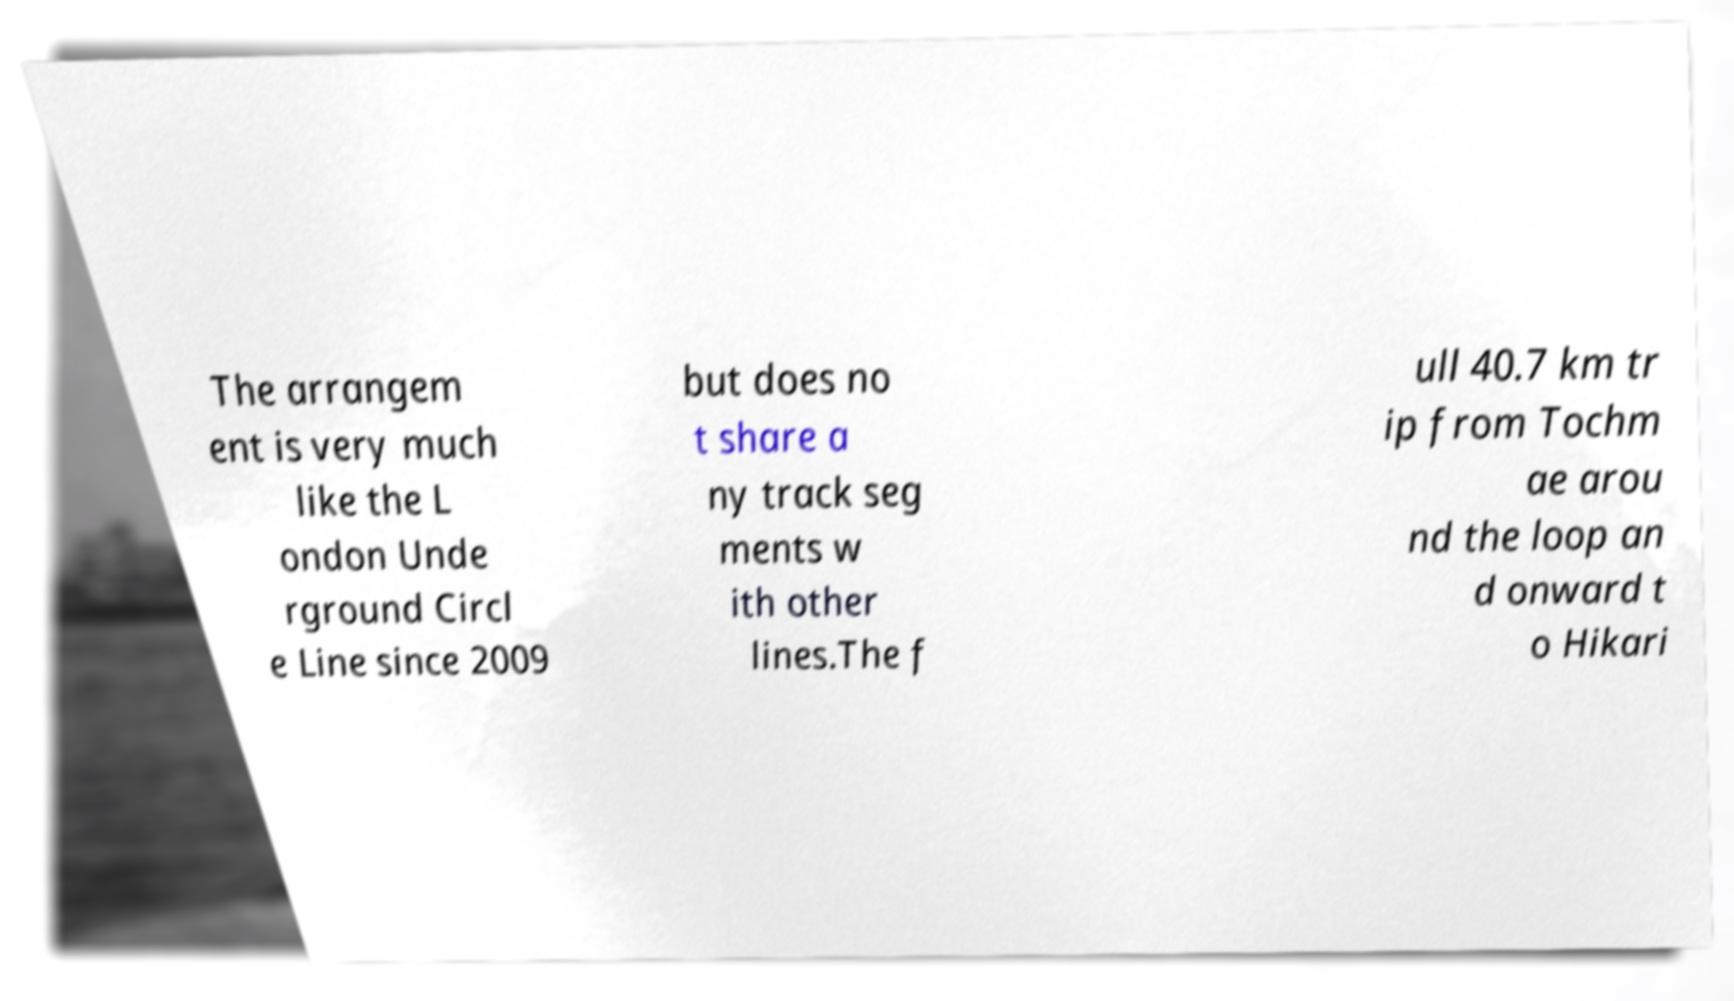There's text embedded in this image that I need extracted. Can you transcribe it verbatim? The arrangem ent is very much like the L ondon Unde rground Circl e Line since 2009 but does no t share a ny track seg ments w ith other lines.The f ull 40.7 km tr ip from Tochm ae arou nd the loop an d onward t o Hikari 